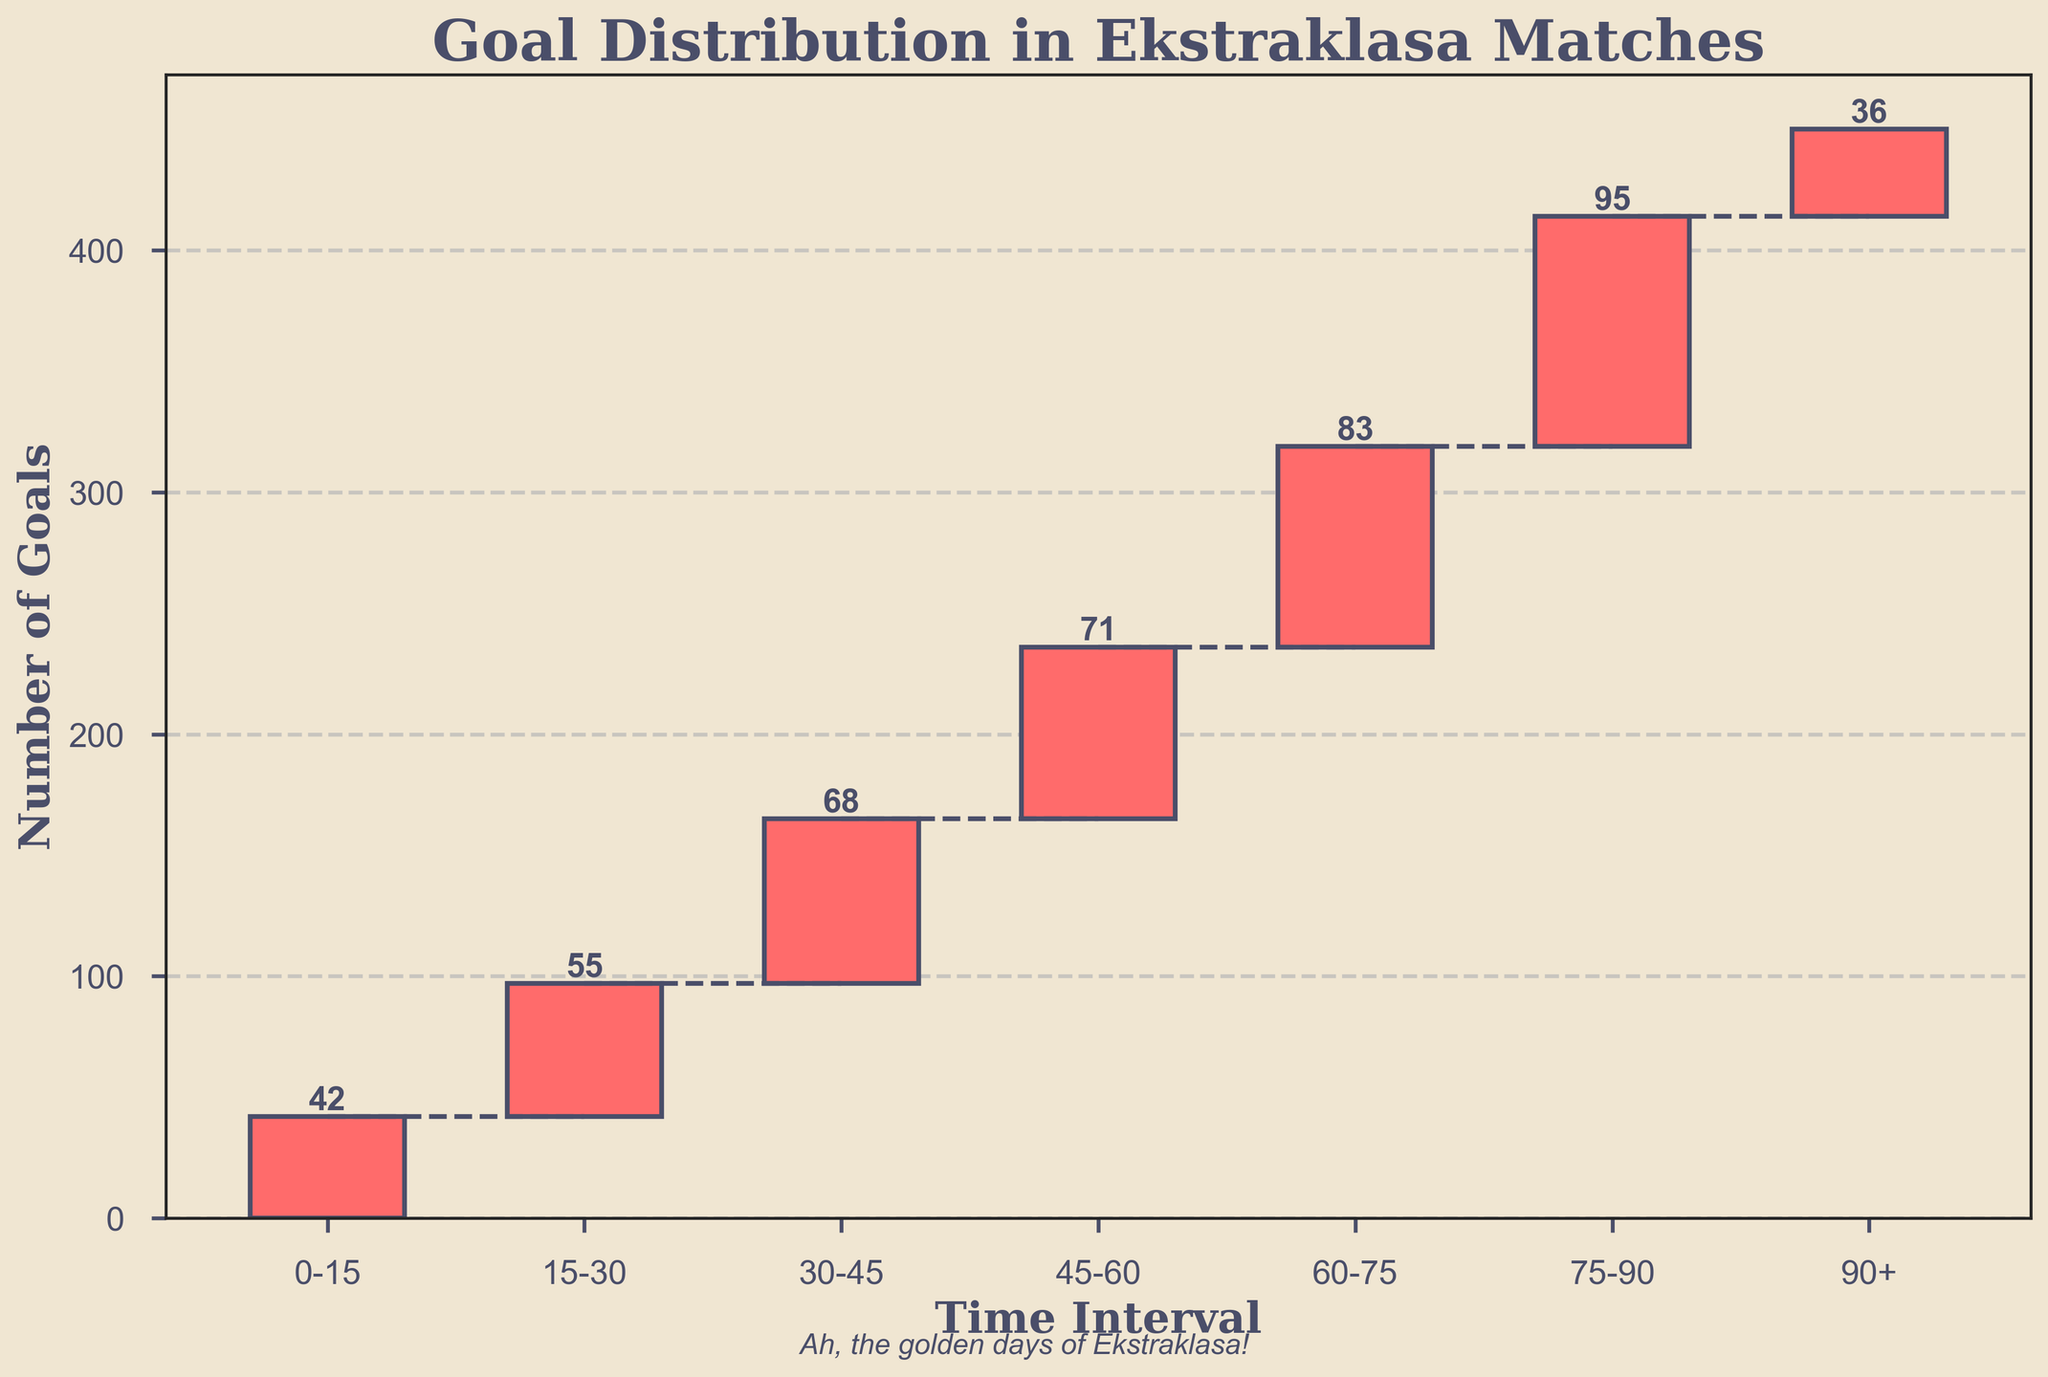What's the title of the figure? Look at the top of the figure where the title is usually located.
Answer: Goal Distribution in Ekstraklasa Matches What is the highest number of goals scored in a single 15-minute interval? Check each bar and read the numbers at the top of the bars to find the highest value.
Answer: 95 How many time intervals are plotted in the figure? Count the number of bars or the number of intervals on the x-axis.
Answer: 7 Which time interval has the fewest goals? Look at the height of each bar and identify the interval with the smallest number on top.
Answer: 90+ How many total goals are scored in the first half of the matches? Add the goals for the intervals within the first 45 minutes (0-15, 15-30, 30-45). 42 + 55 + 68 = 165
Answer: 165 Which time interval shows the biggest increase in goals compared to the previous interval? Calculate the difference in goals for each consecutive pair of intervals and find the largest difference. Differences: (55-42), (68-55), (71-68), (83-71), (95-83), (36-95) → 55-42=13, 68-55=13, 71-68=3, 83-71=12, 95-83=12, 36-95=-59
Answer: 15-30 and 30-45 What is the cumulative number of goals by the end of the 60-75 interval? Add the goals up to the end of the 60-75 interval (42 + 55 + 68 + 71 + 83). 42 + 55 + 68 + 71 + 83 = 319
Answer: 319 How many total goals are scored during the second half of the matches, including added time? Add the goals for the intervals within the second half (45-60, 60-75, 75-90, 90+). 71 + 83 + 95 + 36 = 285
Answer: 285 Which pair of consecutive 15-minute intervals have the least difference in goals? Calculate the absolute difference in goals for each consecutive pair and find the smallest difference. Differences: (55-42), (68-55), (71-68), (83-71), (95-83), (36-95) → 55-42=13, 68-55=13, 71-68=3, 83-71=12, 95-83=12, 36-95=59
Answer: 30-45 and 45-60 